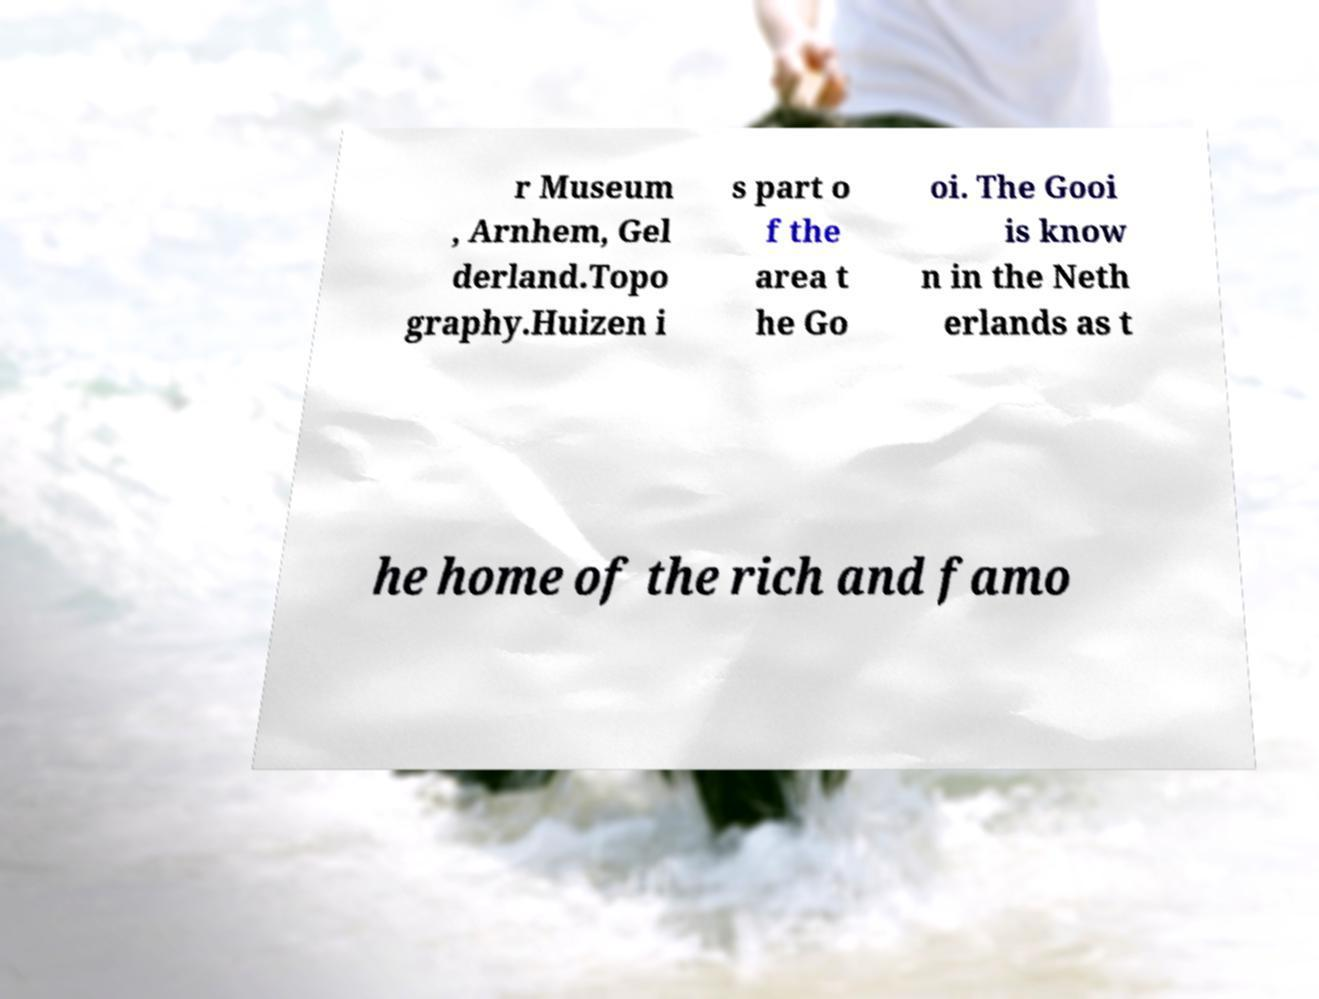For documentation purposes, I need the text within this image transcribed. Could you provide that? r Museum , Arnhem, Gel derland.Topo graphy.Huizen i s part o f the area t he Go oi. The Gooi is know n in the Neth erlands as t he home of the rich and famo 